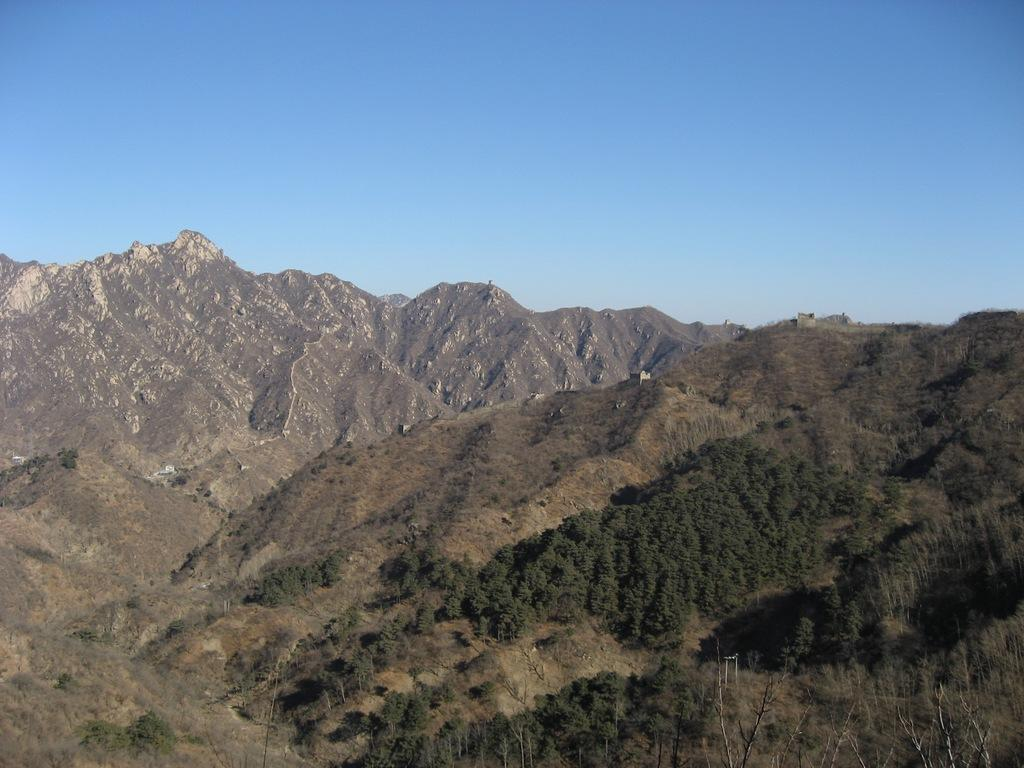What is located in the center of the image? There are trees in the center of the image. What can be seen in the background of the image? There are mountains in the background of the image. What type of soap is hanging from the trees in the image? There is no soap present in the image; it features trees and mountains. What time is indicated on the watch in the image? There is no watch present in the image. 